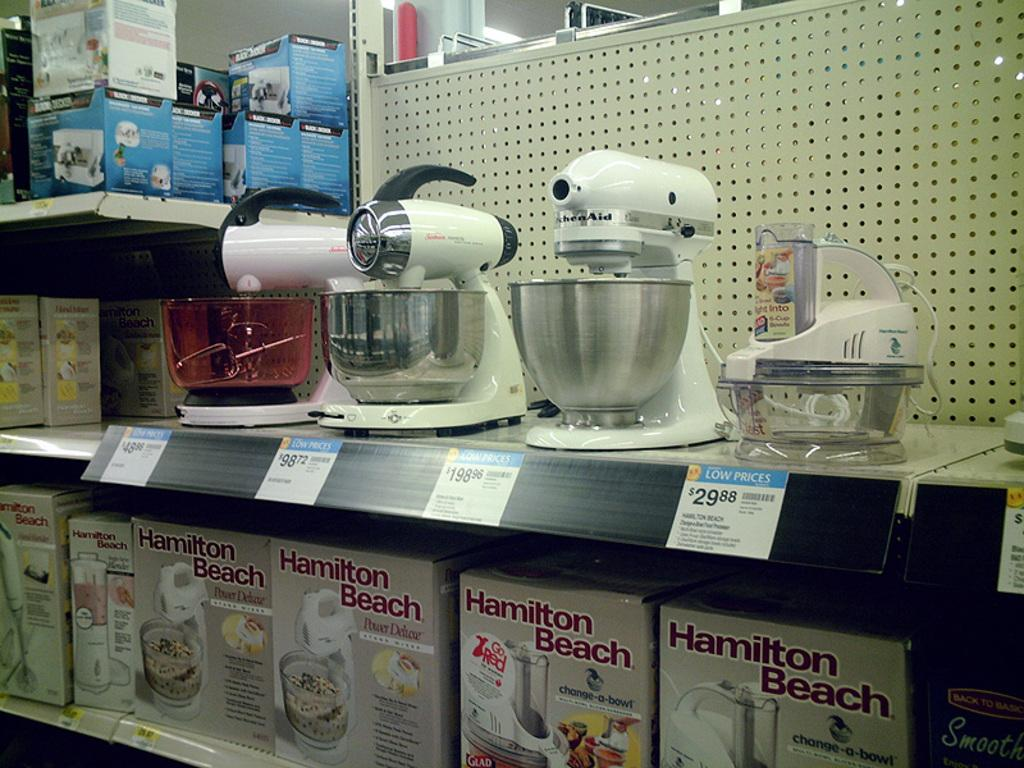<image>
Create a compact narrative representing the image presented. A store aisle with lots of Kitchen-Aid products with tags that say low prices. 